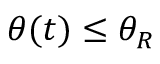<formula> <loc_0><loc_0><loc_500><loc_500>\theta ( t ) \leq \theta _ { R }</formula> 